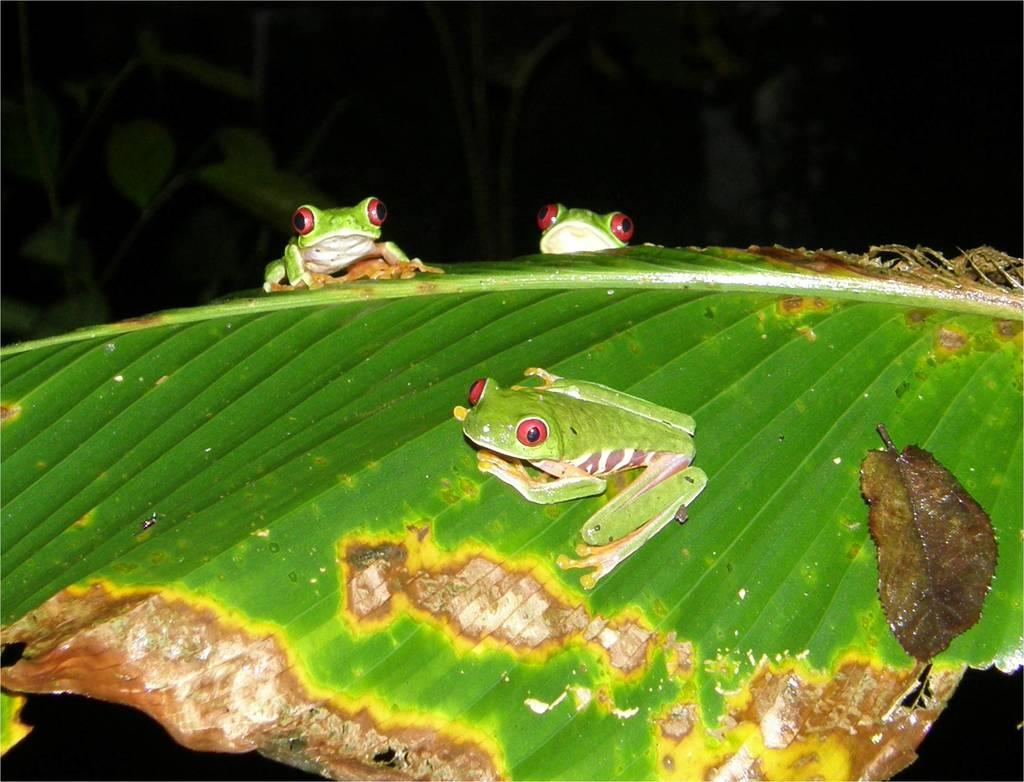What animals are present in the image? There are three green frogs in the image. Where are the frogs located? The frogs are on a leaf. What color are the frogs' eyes? The frogs' eyes are red. What can be seen in the background of the image? There are plants in the background of the image. What type of jail can be seen in the image? There is no jail present in the image; it features three green frogs on a leaf. How many jellyfish are swimming in the image? There are no jellyfish present in the image; it features three green frogs on a leaf. 